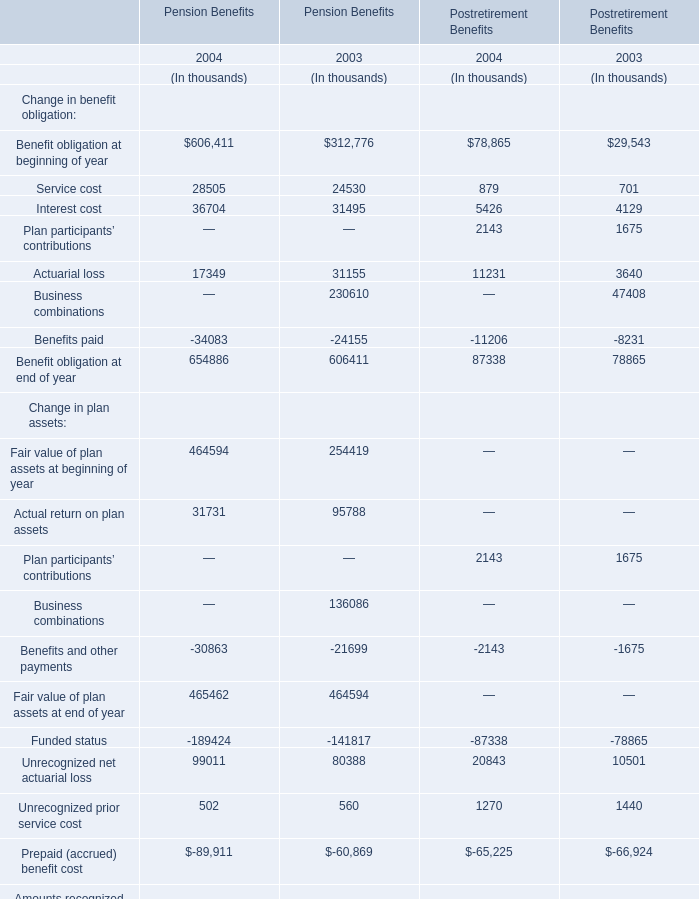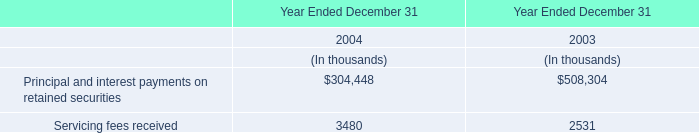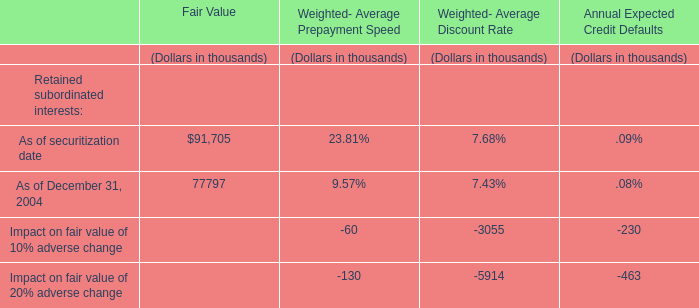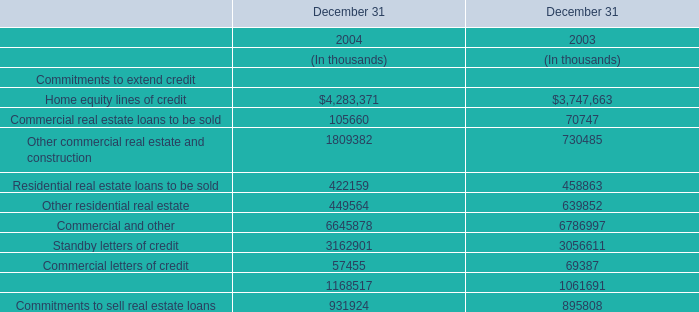What is the average growth rate of Benefits and other payments between 2003 and 2004? 
Computations: ((((-30863 + 21699) / -21699) + ((-2143 + 1675) / -1675)) / 2)
Answer: 0.35086. 